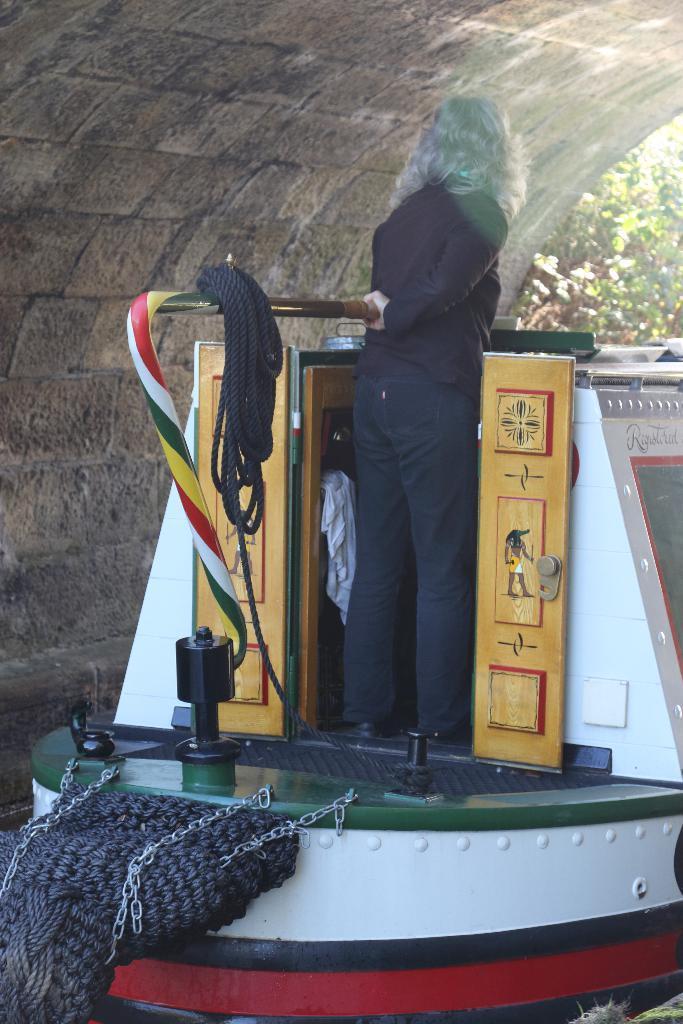In one or two sentences, can you explain what this image depicts? In the center of the image a lady is standing on a boat. In the background of the image we can see wall and trees are there. 